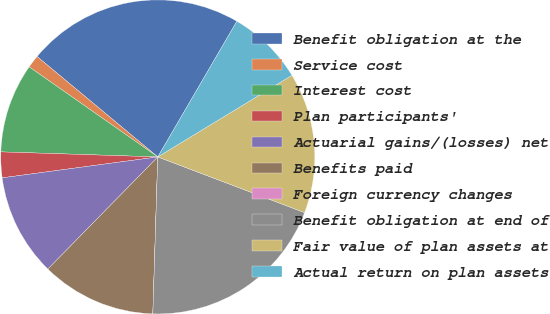Convert chart. <chart><loc_0><loc_0><loc_500><loc_500><pie_chart><fcel>Benefit obligation at the<fcel>Service cost<fcel>Interest cost<fcel>Plan participants'<fcel>Actuarial gains/(losses) net<fcel>Benefits paid<fcel>Foreign currency changes<fcel>Benefit obligation at end of<fcel>Fair value of plan assets at<fcel>Actual return on plan assets<nl><fcel>22.36%<fcel>1.32%<fcel>9.21%<fcel>2.64%<fcel>10.53%<fcel>11.84%<fcel>0.0%<fcel>19.73%<fcel>14.47%<fcel>7.9%<nl></chart> 